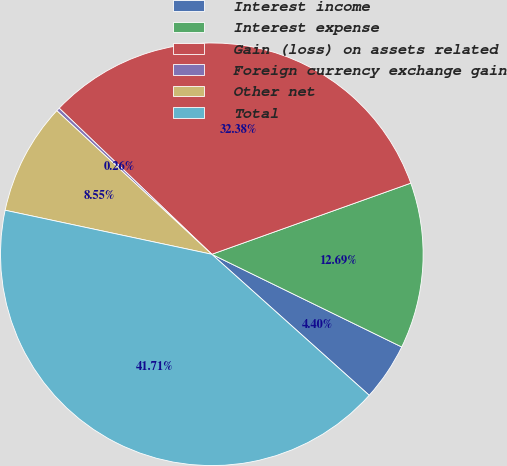Convert chart to OTSL. <chart><loc_0><loc_0><loc_500><loc_500><pie_chart><fcel>Interest income<fcel>Interest expense<fcel>Gain (loss) on assets related<fcel>Foreign currency exchange gain<fcel>Other net<fcel>Total<nl><fcel>4.4%<fcel>12.69%<fcel>32.38%<fcel>0.26%<fcel>8.55%<fcel>41.71%<nl></chart> 